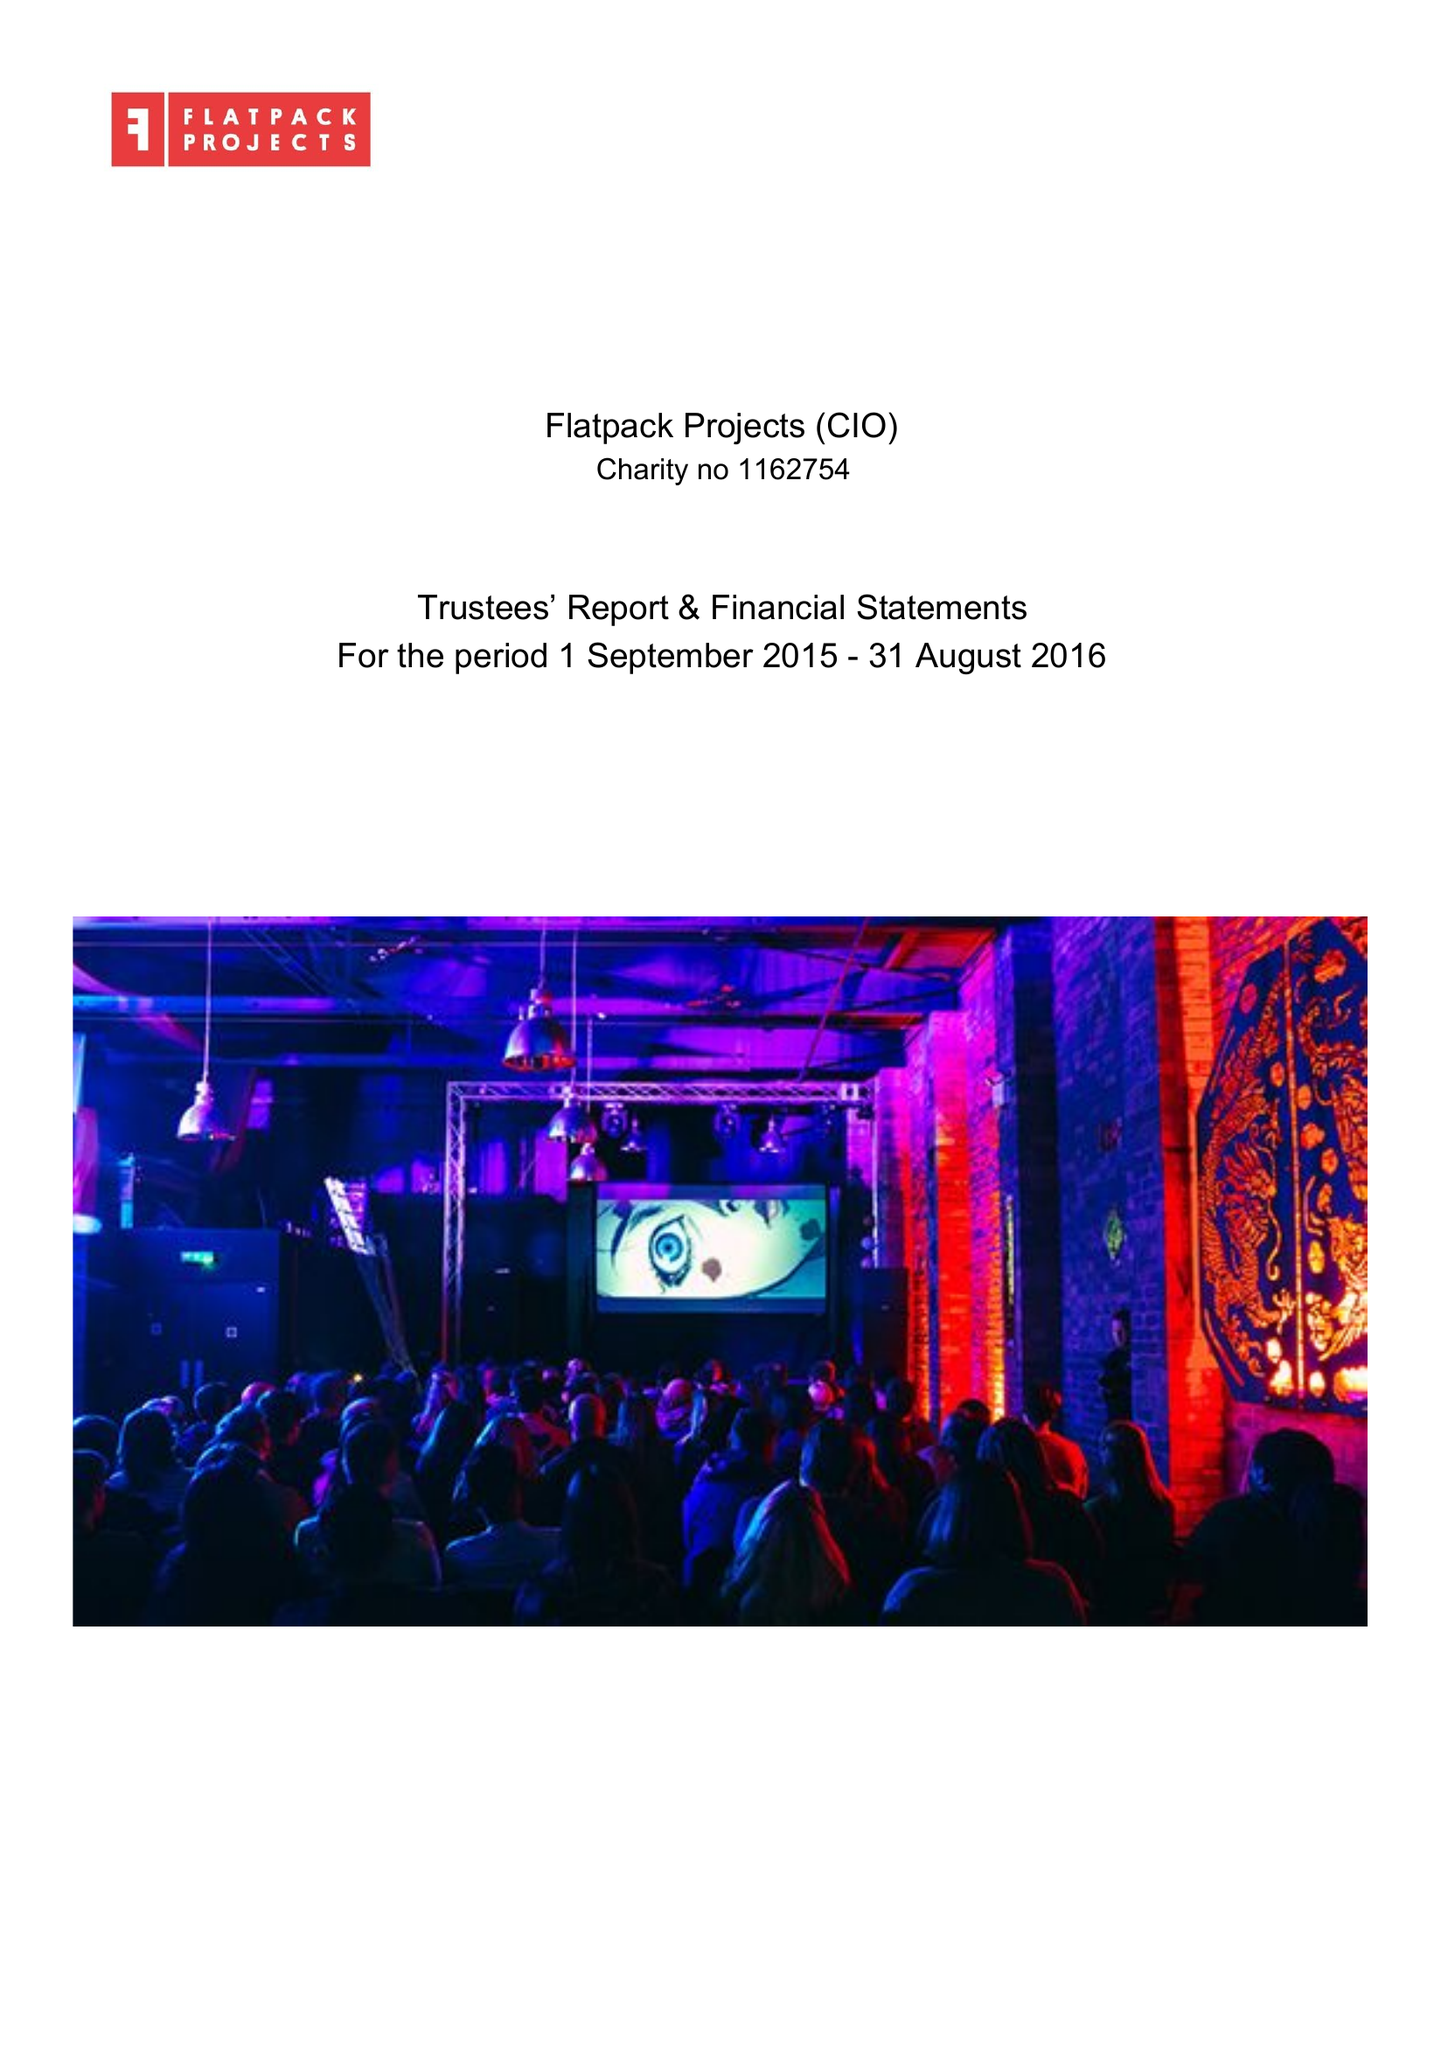What is the value for the report_date?
Answer the question using a single word or phrase. 2016-08-31 